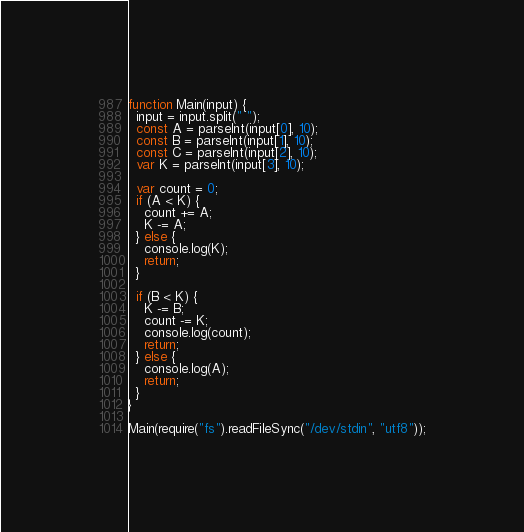<code> <loc_0><loc_0><loc_500><loc_500><_JavaScript_>function Main(input) {
  input = input.split(" ");
  const A = parseInt(input[0], 10);
  const B = parseInt(input[1], 10);
  const C = parseInt(input[2], 10);
  var K = parseInt(input[3], 10);

  var count = 0;
  if (A < K) {
    count += A;
    K -= A;
  } else {
    console.log(K);
    return;
  }

  if (B < K) {
    K -= B;
    count -= K;
    console.log(count);
    return;
  } else {
    console.log(A);
    return;
  }
}

Main(require("fs").readFileSync("/dev/stdin", "utf8"));
</code> 